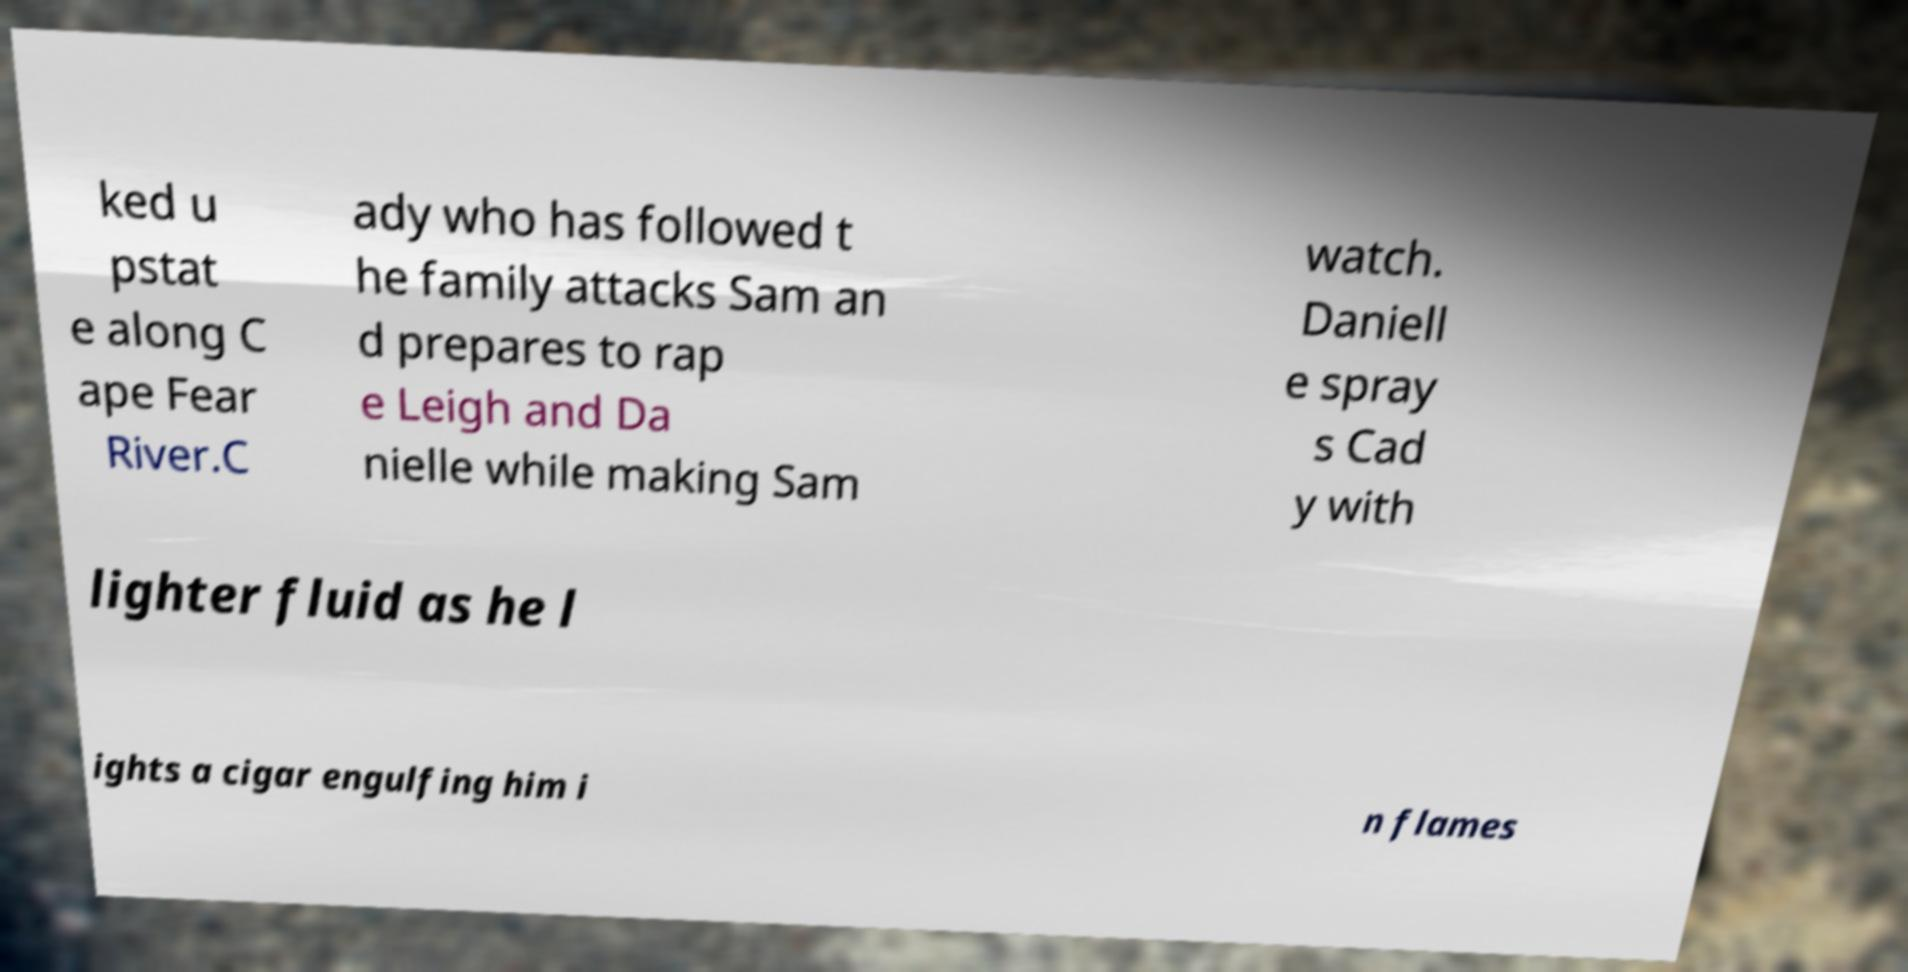Please identify and transcribe the text found in this image. ked u pstat e along C ape Fear River.C ady who has followed t he family attacks Sam an d prepares to rap e Leigh and Da nielle while making Sam watch. Daniell e spray s Cad y with lighter fluid as he l ights a cigar engulfing him i n flames 